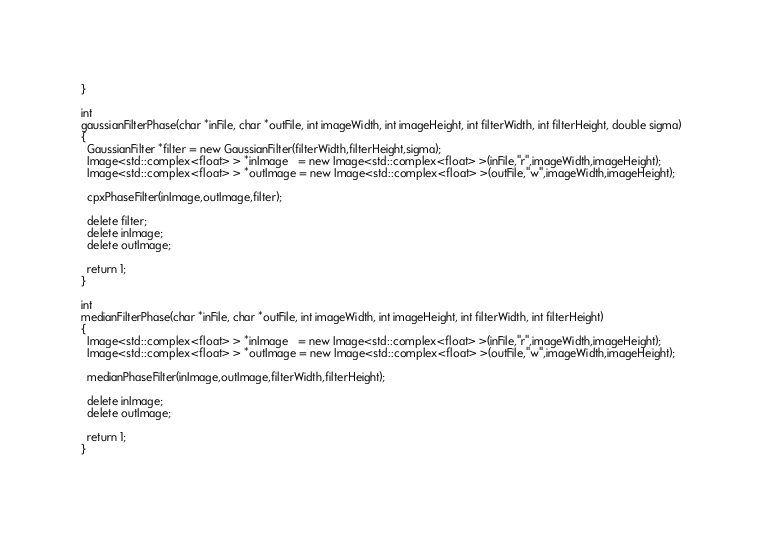Convert code to text. <code><loc_0><loc_0><loc_500><loc_500><_C++_>}

int
gaussianFilterPhase(char *inFile, char *outFile, int imageWidth, int imageHeight, int filterWidth, int filterHeight, double sigma)
{
  GaussianFilter *filter = new GaussianFilter(filterWidth,filterHeight,sigma);
  Image<std::complex<float> > *inImage   = new Image<std::complex<float> >(inFile,"r",imageWidth,imageHeight);
  Image<std::complex<float> > *outImage = new Image<std::complex<float> >(outFile,"w",imageWidth,imageHeight);

  cpxPhaseFilter(inImage,outImage,filter);

  delete filter;
  delete inImage;
  delete outImage;

  return 1;
}

int
medianFilterPhase(char *inFile, char *outFile, int imageWidth, int imageHeight, int filterWidth, int filterHeight)
{
  Image<std::complex<float> > *inImage   = new Image<std::complex<float> >(inFile,"r",imageWidth,imageHeight);
  Image<std::complex<float> > *outImage = new Image<std::complex<float> >(outFile,"w",imageWidth,imageHeight);

  medianPhaseFilter(inImage,outImage,filterWidth,filterHeight);

  delete inImage;
  delete outImage;

  return 1;
}
</code> 